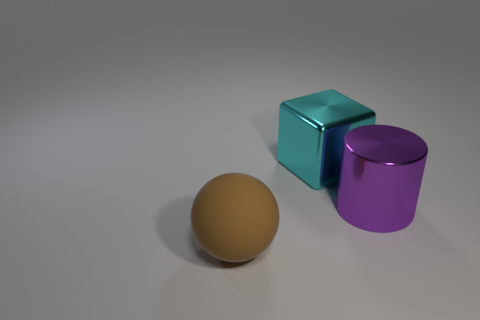Subtract all cylinders. How many objects are left? 2 Add 2 metallic spheres. How many metallic spheres exist? 2 Add 3 purple metal objects. How many objects exist? 6 Subtract 0 cyan cylinders. How many objects are left? 3 Subtract 1 blocks. How many blocks are left? 0 Subtract all purple spheres. Subtract all yellow cubes. How many spheres are left? 1 Subtract all metallic objects. Subtract all rubber spheres. How many objects are left? 0 Add 1 big cyan shiny things. How many big cyan shiny things are left? 2 